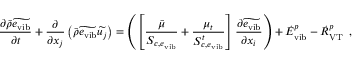Convert formula to latex. <formula><loc_0><loc_0><loc_500><loc_500>\frac { \partial \bar { \rho } \widetilde { e _ { v i b } } } { \partial t } + \frac { \partial } { \partial x _ { j } } \left ( \bar { \rho } \widetilde { e _ { v i b } } \widetilde { u _ { j } } \right ) = \left ( \left [ \frac { \bar { \mu } } { S _ { c , e _ { v i b } } } + \frac { \mu _ { t } } { S _ { c , e _ { v i b } } ^ { t } } \right ] \frac { \partial \widetilde { e _ { v i b } } } { \partial x _ { i } } \right ) + { \dot { E } } _ { v i b } ^ { p } - { \dot { R } } _ { V T } ^ { p } \, ,</formula> 